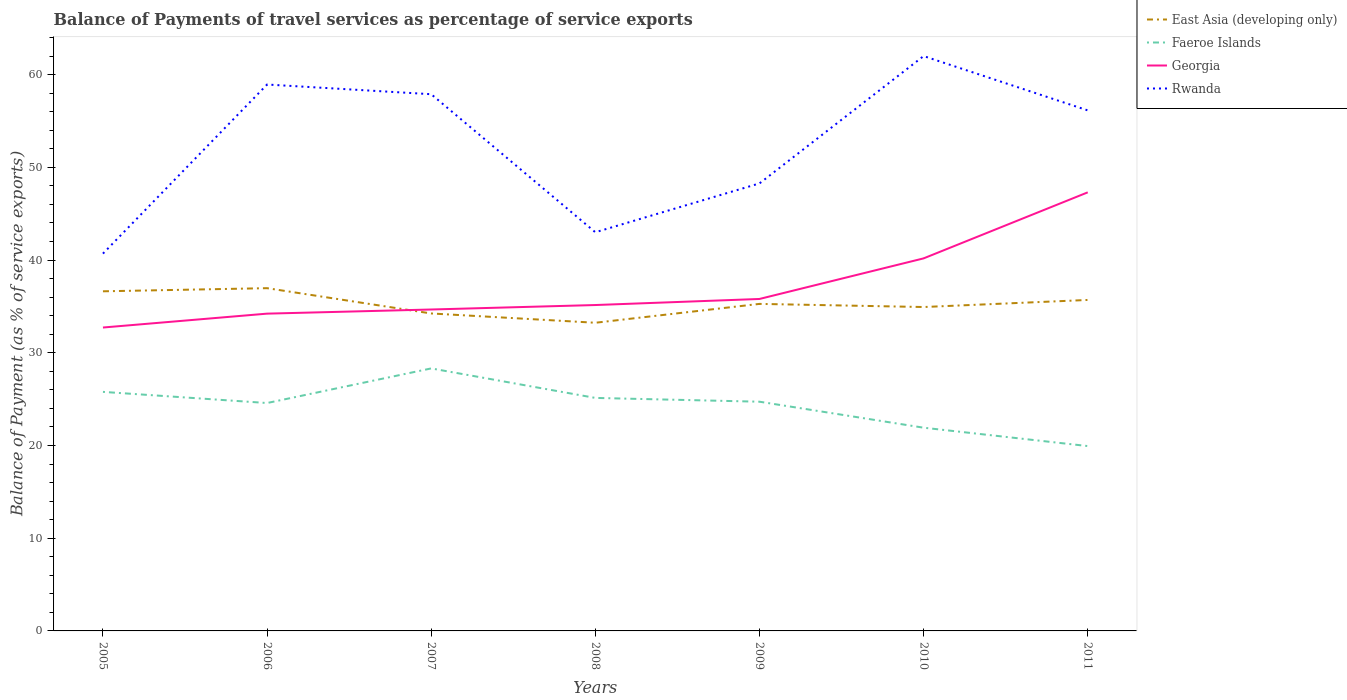How many different coloured lines are there?
Make the answer very short. 4. Is the number of lines equal to the number of legend labels?
Offer a very short reply. Yes. Across all years, what is the maximum balance of payments of travel services in Georgia?
Ensure brevity in your answer.  32.72. What is the total balance of payments of travel services in Rwanda in the graph?
Offer a very short reply. -13.14. What is the difference between the highest and the second highest balance of payments of travel services in Rwanda?
Give a very brief answer. 21.3. Is the balance of payments of travel services in East Asia (developing only) strictly greater than the balance of payments of travel services in Georgia over the years?
Make the answer very short. No. How many lines are there?
Ensure brevity in your answer.  4. What is the difference between two consecutive major ticks on the Y-axis?
Make the answer very short. 10. Are the values on the major ticks of Y-axis written in scientific E-notation?
Your answer should be compact. No. Does the graph contain grids?
Provide a succinct answer. No. Where does the legend appear in the graph?
Your answer should be compact. Top right. How many legend labels are there?
Give a very brief answer. 4. What is the title of the graph?
Offer a terse response. Balance of Payments of travel services as percentage of service exports. Does "Trinidad and Tobago" appear as one of the legend labels in the graph?
Keep it short and to the point. No. What is the label or title of the X-axis?
Your answer should be compact. Years. What is the label or title of the Y-axis?
Offer a terse response. Balance of Payment (as % of service exports). What is the Balance of Payment (as % of service exports) in East Asia (developing only) in 2005?
Your answer should be compact. 36.63. What is the Balance of Payment (as % of service exports) of Faeroe Islands in 2005?
Your answer should be very brief. 25.78. What is the Balance of Payment (as % of service exports) of Georgia in 2005?
Provide a short and direct response. 32.72. What is the Balance of Payment (as % of service exports) in Rwanda in 2005?
Your answer should be very brief. 40.69. What is the Balance of Payment (as % of service exports) in East Asia (developing only) in 2006?
Your answer should be compact. 36.96. What is the Balance of Payment (as % of service exports) of Faeroe Islands in 2006?
Ensure brevity in your answer.  24.58. What is the Balance of Payment (as % of service exports) in Georgia in 2006?
Provide a succinct answer. 34.22. What is the Balance of Payment (as % of service exports) in Rwanda in 2006?
Provide a short and direct response. 58.93. What is the Balance of Payment (as % of service exports) in East Asia (developing only) in 2007?
Offer a very short reply. 34.24. What is the Balance of Payment (as % of service exports) in Faeroe Islands in 2007?
Keep it short and to the point. 28.31. What is the Balance of Payment (as % of service exports) of Georgia in 2007?
Make the answer very short. 34.66. What is the Balance of Payment (as % of service exports) of Rwanda in 2007?
Provide a short and direct response. 57.88. What is the Balance of Payment (as % of service exports) of East Asia (developing only) in 2008?
Provide a short and direct response. 33.23. What is the Balance of Payment (as % of service exports) in Faeroe Islands in 2008?
Offer a very short reply. 25.13. What is the Balance of Payment (as % of service exports) in Georgia in 2008?
Keep it short and to the point. 35.15. What is the Balance of Payment (as % of service exports) in Rwanda in 2008?
Provide a succinct answer. 42.99. What is the Balance of Payment (as % of service exports) in East Asia (developing only) in 2009?
Your answer should be very brief. 35.27. What is the Balance of Payment (as % of service exports) of Faeroe Islands in 2009?
Provide a short and direct response. 24.72. What is the Balance of Payment (as % of service exports) of Georgia in 2009?
Your answer should be very brief. 35.8. What is the Balance of Payment (as % of service exports) of Rwanda in 2009?
Your answer should be compact. 48.26. What is the Balance of Payment (as % of service exports) in East Asia (developing only) in 2010?
Keep it short and to the point. 34.93. What is the Balance of Payment (as % of service exports) in Faeroe Islands in 2010?
Keep it short and to the point. 21.92. What is the Balance of Payment (as % of service exports) of Georgia in 2010?
Keep it short and to the point. 40.18. What is the Balance of Payment (as % of service exports) of Rwanda in 2010?
Keep it short and to the point. 61.99. What is the Balance of Payment (as % of service exports) in East Asia (developing only) in 2011?
Keep it short and to the point. 35.69. What is the Balance of Payment (as % of service exports) in Faeroe Islands in 2011?
Make the answer very short. 19.94. What is the Balance of Payment (as % of service exports) of Georgia in 2011?
Offer a terse response. 47.3. What is the Balance of Payment (as % of service exports) of Rwanda in 2011?
Provide a short and direct response. 56.14. Across all years, what is the maximum Balance of Payment (as % of service exports) of East Asia (developing only)?
Your answer should be very brief. 36.96. Across all years, what is the maximum Balance of Payment (as % of service exports) of Faeroe Islands?
Your response must be concise. 28.31. Across all years, what is the maximum Balance of Payment (as % of service exports) of Georgia?
Your answer should be very brief. 47.3. Across all years, what is the maximum Balance of Payment (as % of service exports) of Rwanda?
Your response must be concise. 61.99. Across all years, what is the minimum Balance of Payment (as % of service exports) of East Asia (developing only)?
Make the answer very short. 33.23. Across all years, what is the minimum Balance of Payment (as % of service exports) in Faeroe Islands?
Keep it short and to the point. 19.94. Across all years, what is the minimum Balance of Payment (as % of service exports) in Georgia?
Keep it short and to the point. 32.72. Across all years, what is the minimum Balance of Payment (as % of service exports) of Rwanda?
Provide a succinct answer. 40.69. What is the total Balance of Payment (as % of service exports) in East Asia (developing only) in the graph?
Give a very brief answer. 246.95. What is the total Balance of Payment (as % of service exports) in Faeroe Islands in the graph?
Offer a terse response. 170.37. What is the total Balance of Payment (as % of service exports) in Georgia in the graph?
Give a very brief answer. 260.02. What is the total Balance of Payment (as % of service exports) of Rwanda in the graph?
Provide a succinct answer. 366.89. What is the difference between the Balance of Payment (as % of service exports) in East Asia (developing only) in 2005 and that in 2006?
Give a very brief answer. -0.34. What is the difference between the Balance of Payment (as % of service exports) in Faeroe Islands in 2005 and that in 2006?
Your response must be concise. 1.2. What is the difference between the Balance of Payment (as % of service exports) of Georgia in 2005 and that in 2006?
Offer a terse response. -1.5. What is the difference between the Balance of Payment (as % of service exports) of Rwanda in 2005 and that in 2006?
Keep it short and to the point. -18.23. What is the difference between the Balance of Payment (as % of service exports) in East Asia (developing only) in 2005 and that in 2007?
Your response must be concise. 2.39. What is the difference between the Balance of Payment (as % of service exports) of Faeroe Islands in 2005 and that in 2007?
Your answer should be very brief. -2.53. What is the difference between the Balance of Payment (as % of service exports) of Georgia in 2005 and that in 2007?
Offer a very short reply. -1.94. What is the difference between the Balance of Payment (as % of service exports) in Rwanda in 2005 and that in 2007?
Your answer should be compact. -17.19. What is the difference between the Balance of Payment (as % of service exports) in East Asia (developing only) in 2005 and that in 2008?
Offer a very short reply. 3.39. What is the difference between the Balance of Payment (as % of service exports) in Faeroe Islands in 2005 and that in 2008?
Offer a terse response. 0.65. What is the difference between the Balance of Payment (as % of service exports) in Georgia in 2005 and that in 2008?
Ensure brevity in your answer.  -2.43. What is the difference between the Balance of Payment (as % of service exports) of Rwanda in 2005 and that in 2008?
Your answer should be very brief. -2.3. What is the difference between the Balance of Payment (as % of service exports) in East Asia (developing only) in 2005 and that in 2009?
Ensure brevity in your answer.  1.36. What is the difference between the Balance of Payment (as % of service exports) in Faeroe Islands in 2005 and that in 2009?
Offer a very short reply. 1.06. What is the difference between the Balance of Payment (as % of service exports) of Georgia in 2005 and that in 2009?
Give a very brief answer. -3.08. What is the difference between the Balance of Payment (as % of service exports) of Rwanda in 2005 and that in 2009?
Ensure brevity in your answer.  -7.57. What is the difference between the Balance of Payment (as % of service exports) in East Asia (developing only) in 2005 and that in 2010?
Your answer should be very brief. 1.7. What is the difference between the Balance of Payment (as % of service exports) in Faeroe Islands in 2005 and that in 2010?
Give a very brief answer. 3.86. What is the difference between the Balance of Payment (as % of service exports) of Georgia in 2005 and that in 2010?
Provide a succinct answer. -7.46. What is the difference between the Balance of Payment (as % of service exports) of Rwanda in 2005 and that in 2010?
Provide a short and direct response. -21.3. What is the difference between the Balance of Payment (as % of service exports) in East Asia (developing only) in 2005 and that in 2011?
Ensure brevity in your answer.  0.93. What is the difference between the Balance of Payment (as % of service exports) of Faeroe Islands in 2005 and that in 2011?
Make the answer very short. 5.84. What is the difference between the Balance of Payment (as % of service exports) of Georgia in 2005 and that in 2011?
Offer a very short reply. -14.58. What is the difference between the Balance of Payment (as % of service exports) of Rwanda in 2005 and that in 2011?
Make the answer very short. -15.45. What is the difference between the Balance of Payment (as % of service exports) of East Asia (developing only) in 2006 and that in 2007?
Offer a very short reply. 2.73. What is the difference between the Balance of Payment (as % of service exports) of Faeroe Islands in 2006 and that in 2007?
Ensure brevity in your answer.  -3.73. What is the difference between the Balance of Payment (as % of service exports) of Georgia in 2006 and that in 2007?
Your answer should be very brief. -0.45. What is the difference between the Balance of Payment (as % of service exports) of Rwanda in 2006 and that in 2007?
Keep it short and to the point. 1.05. What is the difference between the Balance of Payment (as % of service exports) of East Asia (developing only) in 2006 and that in 2008?
Offer a terse response. 3.73. What is the difference between the Balance of Payment (as % of service exports) in Faeroe Islands in 2006 and that in 2008?
Your response must be concise. -0.55. What is the difference between the Balance of Payment (as % of service exports) in Georgia in 2006 and that in 2008?
Your answer should be very brief. -0.93. What is the difference between the Balance of Payment (as % of service exports) in Rwanda in 2006 and that in 2008?
Your answer should be very brief. 15.93. What is the difference between the Balance of Payment (as % of service exports) of East Asia (developing only) in 2006 and that in 2009?
Your response must be concise. 1.7. What is the difference between the Balance of Payment (as % of service exports) of Faeroe Islands in 2006 and that in 2009?
Your response must be concise. -0.14. What is the difference between the Balance of Payment (as % of service exports) in Georgia in 2006 and that in 2009?
Your answer should be very brief. -1.58. What is the difference between the Balance of Payment (as % of service exports) in Rwanda in 2006 and that in 2009?
Your response must be concise. 10.66. What is the difference between the Balance of Payment (as % of service exports) of East Asia (developing only) in 2006 and that in 2010?
Your answer should be compact. 2.03. What is the difference between the Balance of Payment (as % of service exports) in Faeroe Islands in 2006 and that in 2010?
Provide a short and direct response. 2.66. What is the difference between the Balance of Payment (as % of service exports) in Georgia in 2006 and that in 2010?
Your answer should be compact. -5.96. What is the difference between the Balance of Payment (as % of service exports) of Rwanda in 2006 and that in 2010?
Your answer should be very brief. -3.07. What is the difference between the Balance of Payment (as % of service exports) of East Asia (developing only) in 2006 and that in 2011?
Keep it short and to the point. 1.27. What is the difference between the Balance of Payment (as % of service exports) of Faeroe Islands in 2006 and that in 2011?
Keep it short and to the point. 4.64. What is the difference between the Balance of Payment (as % of service exports) of Georgia in 2006 and that in 2011?
Give a very brief answer. -13.08. What is the difference between the Balance of Payment (as % of service exports) of Rwanda in 2006 and that in 2011?
Offer a terse response. 2.79. What is the difference between the Balance of Payment (as % of service exports) of Faeroe Islands in 2007 and that in 2008?
Your answer should be very brief. 3.18. What is the difference between the Balance of Payment (as % of service exports) of Georgia in 2007 and that in 2008?
Your answer should be compact. -0.48. What is the difference between the Balance of Payment (as % of service exports) of Rwanda in 2007 and that in 2008?
Give a very brief answer. 14.89. What is the difference between the Balance of Payment (as % of service exports) of East Asia (developing only) in 2007 and that in 2009?
Your response must be concise. -1.03. What is the difference between the Balance of Payment (as % of service exports) in Faeroe Islands in 2007 and that in 2009?
Your answer should be very brief. 3.59. What is the difference between the Balance of Payment (as % of service exports) of Georgia in 2007 and that in 2009?
Your answer should be very brief. -1.14. What is the difference between the Balance of Payment (as % of service exports) of Rwanda in 2007 and that in 2009?
Offer a terse response. 9.62. What is the difference between the Balance of Payment (as % of service exports) of East Asia (developing only) in 2007 and that in 2010?
Your response must be concise. -0.69. What is the difference between the Balance of Payment (as % of service exports) in Faeroe Islands in 2007 and that in 2010?
Provide a succinct answer. 6.39. What is the difference between the Balance of Payment (as % of service exports) of Georgia in 2007 and that in 2010?
Your response must be concise. -5.51. What is the difference between the Balance of Payment (as % of service exports) of Rwanda in 2007 and that in 2010?
Your answer should be very brief. -4.11. What is the difference between the Balance of Payment (as % of service exports) of East Asia (developing only) in 2007 and that in 2011?
Your answer should be compact. -1.46. What is the difference between the Balance of Payment (as % of service exports) of Faeroe Islands in 2007 and that in 2011?
Make the answer very short. 8.37. What is the difference between the Balance of Payment (as % of service exports) of Georgia in 2007 and that in 2011?
Ensure brevity in your answer.  -12.63. What is the difference between the Balance of Payment (as % of service exports) in Rwanda in 2007 and that in 2011?
Your answer should be very brief. 1.74. What is the difference between the Balance of Payment (as % of service exports) of East Asia (developing only) in 2008 and that in 2009?
Your answer should be very brief. -2.03. What is the difference between the Balance of Payment (as % of service exports) of Faeroe Islands in 2008 and that in 2009?
Your answer should be very brief. 0.41. What is the difference between the Balance of Payment (as % of service exports) of Georgia in 2008 and that in 2009?
Keep it short and to the point. -0.65. What is the difference between the Balance of Payment (as % of service exports) of Rwanda in 2008 and that in 2009?
Ensure brevity in your answer.  -5.27. What is the difference between the Balance of Payment (as % of service exports) in East Asia (developing only) in 2008 and that in 2010?
Offer a very short reply. -1.7. What is the difference between the Balance of Payment (as % of service exports) of Faeroe Islands in 2008 and that in 2010?
Provide a succinct answer. 3.21. What is the difference between the Balance of Payment (as % of service exports) of Georgia in 2008 and that in 2010?
Make the answer very short. -5.03. What is the difference between the Balance of Payment (as % of service exports) of East Asia (developing only) in 2008 and that in 2011?
Give a very brief answer. -2.46. What is the difference between the Balance of Payment (as % of service exports) in Faeroe Islands in 2008 and that in 2011?
Keep it short and to the point. 5.19. What is the difference between the Balance of Payment (as % of service exports) of Georgia in 2008 and that in 2011?
Ensure brevity in your answer.  -12.15. What is the difference between the Balance of Payment (as % of service exports) in Rwanda in 2008 and that in 2011?
Make the answer very short. -13.14. What is the difference between the Balance of Payment (as % of service exports) of East Asia (developing only) in 2009 and that in 2010?
Offer a very short reply. 0.34. What is the difference between the Balance of Payment (as % of service exports) of Faeroe Islands in 2009 and that in 2010?
Provide a short and direct response. 2.8. What is the difference between the Balance of Payment (as % of service exports) of Georgia in 2009 and that in 2010?
Your answer should be very brief. -4.38. What is the difference between the Balance of Payment (as % of service exports) in Rwanda in 2009 and that in 2010?
Provide a short and direct response. -13.73. What is the difference between the Balance of Payment (as % of service exports) of East Asia (developing only) in 2009 and that in 2011?
Keep it short and to the point. -0.43. What is the difference between the Balance of Payment (as % of service exports) in Faeroe Islands in 2009 and that in 2011?
Offer a very short reply. 4.78. What is the difference between the Balance of Payment (as % of service exports) of Georgia in 2009 and that in 2011?
Offer a terse response. -11.5. What is the difference between the Balance of Payment (as % of service exports) of Rwanda in 2009 and that in 2011?
Your answer should be compact. -7.88. What is the difference between the Balance of Payment (as % of service exports) in East Asia (developing only) in 2010 and that in 2011?
Provide a short and direct response. -0.76. What is the difference between the Balance of Payment (as % of service exports) of Faeroe Islands in 2010 and that in 2011?
Your response must be concise. 1.98. What is the difference between the Balance of Payment (as % of service exports) of Georgia in 2010 and that in 2011?
Your answer should be very brief. -7.12. What is the difference between the Balance of Payment (as % of service exports) of Rwanda in 2010 and that in 2011?
Make the answer very short. 5.86. What is the difference between the Balance of Payment (as % of service exports) of East Asia (developing only) in 2005 and the Balance of Payment (as % of service exports) of Faeroe Islands in 2006?
Ensure brevity in your answer.  12.05. What is the difference between the Balance of Payment (as % of service exports) of East Asia (developing only) in 2005 and the Balance of Payment (as % of service exports) of Georgia in 2006?
Ensure brevity in your answer.  2.41. What is the difference between the Balance of Payment (as % of service exports) of East Asia (developing only) in 2005 and the Balance of Payment (as % of service exports) of Rwanda in 2006?
Ensure brevity in your answer.  -22.3. What is the difference between the Balance of Payment (as % of service exports) of Faeroe Islands in 2005 and the Balance of Payment (as % of service exports) of Georgia in 2006?
Offer a terse response. -8.44. What is the difference between the Balance of Payment (as % of service exports) of Faeroe Islands in 2005 and the Balance of Payment (as % of service exports) of Rwanda in 2006?
Ensure brevity in your answer.  -33.15. What is the difference between the Balance of Payment (as % of service exports) in Georgia in 2005 and the Balance of Payment (as % of service exports) in Rwanda in 2006?
Offer a terse response. -26.21. What is the difference between the Balance of Payment (as % of service exports) in East Asia (developing only) in 2005 and the Balance of Payment (as % of service exports) in Faeroe Islands in 2007?
Your response must be concise. 8.32. What is the difference between the Balance of Payment (as % of service exports) of East Asia (developing only) in 2005 and the Balance of Payment (as % of service exports) of Georgia in 2007?
Offer a terse response. 1.96. What is the difference between the Balance of Payment (as % of service exports) in East Asia (developing only) in 2005 and the Balance of Payment (as % of service exports) in Rwanda in 2007?
Your response must be concise. -21.25. What is the difference between the Balance of Payment (as % of service exports) in Faeroe Islands in 2005 and the Balance of Payment (as % of service exports) in Georgia in 2007?
Ensure brevity in your answer.  -8.88. What is the difference between the Balance of Payment (as % of service exports) in Faeroe Islands in 2005 and the Balance of Payment (as % of service exports) in Rwanda in 2007?
Ensure brevity in your answer.  -32.1. What is the difference between the Balance of Payment (as % of service exports) of Georgia in 2005 and the Balance of Payment (as % of service exports) of Rwanda in 2007?
Your response must be concise. -25.16. What is the difference between the Balance of Payment (as % of service exports) in East Asia (developing only) in 2005 and the Balance of Payment (as % of service exports) in Faeroe Islands in 2008?
Your response must be concise. 11.5. What is the difference between the Balance of Payment (as % of service exports) of East Asia (developing only) in 2005 and the Balance of Payment (as % of service exports) of Georgia in 2008?
Ensure brevity in your answer.  1.48. What is the difference between the Balance of Payment (as % of service exports) in East Asia (developing only) in 2005 and the Balance of Payment (as % of service exports) in Rwanda in 2008?
Keep it short and to the point. -6.37. What is the difference between the Balance of Payment (as % of service exports) in Faeroe Islands in 2005 and the Balance of Payment (as % of service exports) in Georgia in 2008?
Make the answer very short. -9.37. What is the difference between the Balance of Payment (as % of service exports) in Faeroe Islands in 2005 and the Balance of Payment (as % of service exports) in Rwanda in 2008?
Make the answer very short. -17.21. What is the difference between the Balance of Payment (as % of service exports) of Georgia in 2005 and the Balance of Payment (as % of service exports) of Rwanda in 2008?
Your answer should be very brief. -10.27. What is the difference between the Balance of Payment (as % of service exports) of East Asia (developing only) in 2005 and the Balance of Payment (as % of service exports) of Faeroe Islands in 2009?
Ensure brevity in your answer.  11.91. What is the difference between the Balance of Payment (as % of service exports) of East Asia (developing only) in 2005 and the Balance of Payment (as % of service exports) of Georgia in 2009?
Ensure brevity in your answer.  0.83. What is the difference between the Balance of Payment (as % of service exports) of East Asia (developing only) in 2005 and the Balance of Payment (as % of service exports) of Rwanda in 2009?
Ensure brevity in your answer.  -11.64. What is the difference between the Balance of Payment (as % of service exports) of Faeroe Islands in 2005 and the Balance of Payment (as % of service exports) of Georgia in 2009?
Give a very brief answer. -10.02. What is the difference between the Balance of Payment (as % of service exports) in Faeroe Islands in 2005 and the Balance of Payment (as % of service exports) in Rwanda in 2009?
Offer a very short reply. -22.48. What is the difference between the Balance of Payment (as % of service exports) in Georgia in 2005 and the Balance of Payment (as % of service exports) in Rwanda in 2009?
Your answer should be compact. -15.54. What is the difference between the Balance of Payment (as % of service exports) in East Asia (developing only) in 2005 and the Balance of Payment (as % of service exports) in Faeroe Islands in 2010?
Ensure brevity in your answer.  14.71. What is the difference between the Balance of Payment (as % of service exports) in East Asia (developing only) in 2005 and the Balance of Payment (as % of service exports) in Georgia in 2010?
Your response must be concise. -3.55. What is the difference between the Balance of Payment (as % of service exports) of East Asia (developing only) in 2005 and the Balance of Payment (as % of service exports) of Rwanda in 2010?
Provide a succinct answer. -25.37. What is the difference between the Balance of Payment (as % of service exports) of Faeroe Islands in 2005 and the Balance of Payment (as % of service exports) of Georgia in 2010?
Your answer should be very brief. -14.4. What is the difference between the Balance of Payment (as % of service exports) in Faeroe Islands in 2005 and the Balance of Payment (as % of service exports) in Rwanda in 2010?
Provide a succinct answer. -36.21. What is the difference between the Balance of Payment (as % of service exports) of Georgia in 2005 and the Balance of Payment (as % of service exports) of Rwanda in 2010?
Make the answer very short. -29.27. What is the difference between the Balance of Payment (as % of service exports) in East Asia (developing only) in 2005 and the Balance of Payment (as % of service exports) in Faeroe Islands in 2011?
Your answer should be compact. 16.69. What is the difference between the Balance of Payment (as % of service exports) of East Asia (developing only) in 2005 and the Balance of Payment (as % of service exports) of Georgia in 2011?
Make the answer very short. -10.67. What is the difference between the Balance of Payment (as % of service exports) of East Asia (developing only) in 2005 and the Balance of Payment (as % of service exports) of Rwanda in 2011?
Give a very brief answer. -19.51. What is the difference between the Balance of Payment (as % of service exports) of Faeroe Islands in 2005 and the Balance of Payment (as % of service exports) of Georgia in 2011?
Offer a very short reply. -21.52. What is the difference between the Balance of Payment (as % of service exports) of Faeroe Islands in 2005 and the Balance of Payment (as % of service exports) of Rwanda in 2011?
Your answer should be compact. -30.36. What is the difference between the Balance of Payment (as % of service exports) in Georgia in 2005 and the Balance of Payment (as % of service exports) in Rwanda in 2011?
Ensure brevity in your answer.  -23.42. What is the difference between the Balance of Payment (as % of service exports) of East Asia (developing only) in 2006 and the Balance of Payment (as % of service exports) of Faeroe Islands in 2007?
Ensure brevity in your answer.  8.65. What is the difference between the Balance of Payment (as % of service exports) in East Asia (developing only) in 2006 and the Balance of Payment (as % of service exports) in Georgia in 2007?
Give a very brief answer. 2.3. What is the difference between the Balance of Payment (as % of service exports) in East Asia (developing only) in 2006 and the Balance of Payment (as % of service exports) in Rwanda in 2007?
Provide a short and direct response. -20.92. What is the difference between the Balance of Payment (as % of service exports) in Faeroe Islands in 2006 and the Balance of Payment (as % of service exports) in Georgia in 2007?
Offer a terse response. -10.09. What is the difference between the Balance of Payment (as % of service exports) of Faeroe Islands in 2006 and the Balance of Payment (as % of service exports) of Rwanda in 2007?
Provide a short and direct response. -33.3. What is the difference between the Balance of Payment (as % of service exports) of Georgia in 2006 and the Balance of Payment (as % of service exports) of Rwanda in 2007?
Provide a short and direct response. -23.66. What is the difference between the Balance of Payment (as % of service exports) of East Asia (developing only) in 2006 and the Balance of Payment (as % of service exports) of Faeroe Islands in 2008?
Ensure brevity in your answer.  11.84. What is the difference between the Balance of Payment (as % of service exports) in East Asia (developing only) in 2006 and the Balance of Payment (as % of service exports) in Georgia in 2008?
Offer a terse response. 1.82. What is the difference between the Balance of Payment (as % of service exports) of East Asia (developing only) in 2006 and the Balance of Payment (as % of service exports) of Rwanda in 2008?
Make the answer very short. -6.03. What is the difference between the Balance of Payment (as % of service exports) in Faeroe Islands in 2006 and the Balance of Payment (as % of service exports) in Georgia in 2008?
Provide a short and direct response. -10.57. What is the difference between the Balance of Payment (as % of service exports) of Faeroe Islands in 2006 and the Balance of Payment (as % of service exports) of Rwanda in 2008?
Keep it short and to the point. -18.42. What is the difference between the Balance of Payment (as % of service exports) in Georgia in 2006 and the Balance of Payment (as % of service exports) in Rwanda in 2008?
Your response must be concise. -8.78. What is the difference between the Balance of Payment (as % of service exports) of East Asia (developing only) in 2006 and the Balance of Payment (as % of service exports) of Faeroe Islands in 2009?
Your response must be concise. 12.24. What is the difference between the Balance of Payment (as % of service exports) of East Asia (developing only) in 2006 and the Balance of Payment (as % of service exports) of Georgia in 2009?
Keep it short and to the point. 1.16. What is the difference between the Balance of Payment (as % of service exports) in East Asia (developing only) in 2006 and the Balance of Payment (as % of service exports) in Rwanda in 2009?
Give a very brief answer. -11.3. What is the difference between the Balance of Payment (as % of service exports) in Faeroe Islands in 2006 and the Balance of Payment (as % of service exports) in Georgia in 2009?
Provide a short and direct response. -11.22. What is the difference between the Balance of Payment (as % of service exports) in Faeroe Islands in 2006 and the Balance of Payment (as % of service exports) in Rwanda in 2009?
Your response must be concise. -23.68. What is the difference between the Balance of Payment (as % of service exports) of Georgia in 2006 and the Balance of Payment (as % of service exports) of Rwanda in 2009?
Make the answer very short. -14.04. What is the difference between the Balance of Payment (as % of service exports) of East Asia (developing only) in 2006 and the Balance of Payment (as % of service exports) of Faeroe Islands in 2010?
Keep it short and to the point. 15.05. What is the difference between the Balance of Payment (as % of service exports) in East Asia (developing only) in 2006 and the Balance of Payment (as % of service exports) in Georgia in 2010?
Make the answer very short. -3.21. What is the difference between the Balance of Payment (as % of service exports) in East Asia (developing only) in 2006 and the Balance of Payment (as % of service exports) in Rwanda in 2010?
Your answer should be very brief. -25.03. What is the difference between the Balance of Payment (as % of service exports) in Faeroe Islands in 2006 and the Balance of Payment (as % of service exports) in Georgia in 2010?
Keep it short and to the point. -15.6. What is the difference between the Balance of Payment (as % of service exports) of Faeroe Islands in 2006 and the Balance of Payment (as % of service exports) of Rwanda in 2010?
Make the answer very short. -37.42. What is the difference between the Balance of Payment (as % of service exports) in Georgia in 2006 and the Balance of Payment (as % of service exports) in Rwanda in 2010?
Provide a short and direct response. -27.78. What is the difference between the Balance of Payment (as % of service exports) in East Asia (developing only) in 2006 and the Balance of Payment (as % of service exports) in Faeroe Islands in 2011?
Ensure brevity in your answer.  17.03. What is the difference between the Balance of Payment (as % of service exports) in East Asia (developing only) in 2006 and the Balance of Payment (as % of service exports) in Georgia in 2011?
Your answer should be compact. -10.33. What is the difference between the Balance of Payment (as % of service exports) of East Asia (developing only) in 2006 and the Balance of Payment (as % of service exports) of Rwanda in 2011?
Your answer should be very brief. -19.17. What is the difference between the Balance of Payment (as % of service exports) in Faeroe Islands in 2006 and the Balance of Payment (as % of service exports) in Georgia in 2011?
Provide a short and direct response. -22.72. What is the difference between the Balance of Payment (as % of service exports) in Faeroe Islands in 2006 and the Balance of Payment (as % of service exports) in Rwanda in 2011?
Provide a short and direct response. -31.56. What is the difference between the Balance of Payment (as % of service exports) of Georgia in 2006 and the Balance of Payment (as % of service exports) of Rwanda in 2011?
Your answer should be compact. -21.92. What is the difference between the Balance of Payment (as % of service exports) in East Asia (developing only) in 2007 and the Balance of Payment (as % of service exports) in Faeroe Islands in 2008?
Ensure brevity in your answer.  9.11. What is the difference between the Balance of Payment (as % of service exports) of East Asia (developing only) in 2007 and the Balance of Payment (as % of service exports) of Georgia in 2008?
Ensure brevity in your answer.  -0.91. What is the difference between the Balance of Payment (as % of service exports) in East Asia (developing only) in 2007 and the Balance of Payment (as % of service exports) in Rwanda in 2008?
Make the answer very short. -8.76. What is the difference between the Balance of Payment (as % of service exports) in Faeroe Islands in 2007 and the Balance of Payment (as % of service exports) in Georgia in 2008?
Your answer should be very brief. -6.84. What is the difference between the Balance of Payment (as % of service exports) in Faeroe Islands in 2007 and the Balance of Payment (as % of service exports) in Rwanda in 2008?
Give a very brief answer. -14.68. What is the difference between the Balance of Payment (as % of service exports) of Georgia in 2007 and the Balance of Payment (as % of service exports) of Rwanda in 2008?
Keep it short and to the point. -8.33. What is the difference between the Balance of Payment (as % of service exports) in East Asia (developing only) in 2007 and the Balance of Payment (as % of service exports) in Faeroe Islands in 2009?
Ensure brevity in your answer.  9.52. What is the difference between the Balance of Payment (as % of service exports) of East Asia (developing only) in 2007 and the Balance of Payment (as % of service exports) of Georgia in 2009?
Keep it short and to the point. -1.56. What is the difference between the Balance of Payment (as % of service exports) of East Asia (developing only) in 2007 and the Balance of Payment (as % of service exports) of Rwanda in 2009?
Give a very brief answer. -14.03. What is the difference between the Balance of Payment (as % of service exports) in Faeroe Islands in 2007 and the Balance of Payment (as % of service exports) in Georgia in 2009?
Ensure brevity in your answer.  -7.49. What is the difference between the Balance of Payment (as % of service exports) in Faeroe Islands in 2007 and the Balance of Payment (as % of service exports) in Rwanda in 2009?
Your answer should be very brief. -19.95. What is the difference between the Balance of Payment (as % of service exports) of Georgia in 2007 and the Balance of Payment (as % of service exports) of Rwanda in 2009?
Keep it short and to the point. -13.6. What is the difference between the Balance of Payment (as % of service exports) of East Asia (developing only) in 2007 and the Balance of Payment (as % of service exports) of Faeroe Islands in 2010?
Your answer should be compact. 12.32. What is the difference between the Balance of Payment (as % of service exports) of East Asia (developing only) in 2007 and the Balance of Payment (as % of service exports) of Georgia in 2010?
Provide a succinct answer. -5.94. What is the difference between the Balance of Payment (as % of service exports) in East Asia (developing only) in 2007 and the Balance of Payment (as % of service exports) in Rwanda in 2010?
Provide a succinct answer. -27.76. What is the difference between the Balance of Payment (as % of service exports) of Faeroe Islands in 2007 and the Balance of Payment (as % of service exports) of Georgia in 2010?
Make the answer very short. -11.87. What is the difference between the Balance of Payment (as % of service exports) in Faeroe Islands in 2007 and the Balance of Payment (as % of service exports) in Rwanda in 2010?
Provide a succinct answer. -33.68. What is the difference between the Balance of Payment (as % of service exports) of Georgia in 2007 and the Balance of Payment (as % of service exports) of Rwanda in 2010?
Your response must be concise. -27.33. What is the difference between the Balance of Payment (as % of service exports) of East Asia (developing only) in 2007 and the Balance of Payment (as % of service exports) of Faeroe Islands in 2011?
Keep it short and to the point. 14.3. What is the difference between the Balance of Payment (as % of service exports) in East Asia (developing only) in 2007 and the Balance of Payment (as % of service exports) in Georgia in 2011?
Your answer should be compact. -13.06. What is the difference between the Balance of Payment (as % of service exports) in East Asia (developing only) in 2007 and the Balance of Payment (as % of service exports) in Rwanda in 2011?
Offer a very short reply. -21.9. What is the difference between the Balance of Payment (as % of service exports) of Faeroe Islands in 2007 and the Balance of Payment (as % of service exports) of Georgia in 2011?
Keep it short and to the point. -18.99. What is the difference between the Balance of Payment (as % of service exports) in Faeroe Islands in 2007 and the Balance of Payment (as % of service exports) in Rwanda in 2011?
Keep it short and to the point. -27.83. What is the difference between the Balance of Payment (as % of service exports) in Georgia in 2007 and the Balance of Payment (as % of service exports) in Rwanda in 2011?
Provide a succinct answer. -21.47. What is the difference between the Balance of Payment (as % of service exports) of East Asia (developing only) in 2008 and the Balance of Payment (as % of service exports) of Faeroe Islands in 2009?
Make the answer very short. 8.51. What is the difference between the Balance of Payment (as % of service exports) of East Asia (developing only) in 2008 and the Balance of Payment (as % of service exports) of Georgia in 2009?
Provide a short and direct response. -2.57. What is the difference between the Balance of Payment (as % of service exports) of East Asia (developing only) in 2008 and the Balance of Payment (as % of service exports) of Rwanda in 2009?
Your answer should be compact. -15.03. What is the difference between the Balance of Payment (as % of service exports) in Faeroe Islands in 2008 and the Balance of Payment (as % of service exports) in Georgia in 2009?
Make the answer very short. -10.67. What is the difference between the Balance of Payment (as % of service exports) in Faeroe Islands in 2008 and the Balance of Payment (as % of service exports) in Rwanda in 2009?
Give a very brief answer. -23.13. What is the difference between the Balance of Payment (as % of service exports) of Georgia in 2008 and the Balance of Payment (as % of service exports) of Rwanda in 2009?
Your answer should be very brief. -13.12. What is the difference between the Balance of Payment (as % of service exports) of East Asia (developing only) in 2008 and the Balance of Payment (as % of service exports) of Faeroe Islands in 2010?
Your response must be concise. 11.32. What is the difference between the Balance of Payment (as % of service exports) of East Asia (developing only) in 2008 and the Balance of Payment (as % of service exports) of Georgia in 2010?
Offer a very short reply. -6.94. What is the difference between the Balance of Payment (as % of service exports) of East Asia (developing only) in 2008 and the Balance of Payment (as % of service exports) of Rwanda in 2010?
Provide a succinct answer. -28.76. What is the difference between the Balance of Payment (as % of service exports) in Faeroe Islands in 2008 and the Balance of Payment (as % of service exports) in Georgia in 2010?
Offer a terse response. -15.05. What is the difference between the Balance of Payment (as % of service exports) of Faeroe Islands in 2008 and the Balance of Payment (as % of service exports) of Rwanda in 2010?
Your response must be concise. -36.87. What is the difference between the Balance of Payment (as % of service exports) in Georgia in 2008 and the Balance of Payment (as % of service exports) in Rwanda in 2010?
Provide a succinct answer. -26.85. What is the difference between the Balance of Payment (as % of service exports) in East Asia (developing only) in 2008 and the Balance of Payment (as % of service exports) in Faeroe Islands in 2011?
Make the answer very short. 13.3. What is the difference between the Balance of Payment (as % of service exports) in East Asia (developing only) in 2008 and the Balance of Payment (as % of service exports) in Georgia in 2011?
Offer a very short reply. -14.06. What is the difference between the Balance of Payment (as % of service exports) of East Asia (developing only) in 2008 and the Balance of Payment (as % of service exports) of Rwanda in 2011?
Give a very brief answer. -22.9. What is the difference between the Balance of Payment (as % of service exports) in Faeroe Islands in 2008 and the Balance of Payment (as % of service exports) in Georgia in 2011?
Offer a terse response. -22.17. What is the difference between the Balance of Payment (as % of service exports) in Faeroe Islands in 2008 and the Balance of Payment (as % of service exports) in Rwanda in 2011?
Make the answer very short. -31.01. What is the difference between the Balance of Payment (as % of service exports) of Georgia in 2008 and the Balance of Payment (as % of service exports) of Rwanda in 2011?
Your answer should be compact. -20.99. What is the difference between the Balance of Payment (as % of service exports) in East Asia (developing only) in 2009 and the Balance of Payment (as % of service exports) in Faeroe Islands in 2010?
Give a very brief answer. 13.35. What is the difference between the Balance of Payment (as % of service exports) in East Asia (developing only) in 2009 and the Balance of Payment (as % of service exports) in Georgia in 2010?
Provide a succinct answer. -4.91. What is the difference between the Balance of Payment (as % of service exports) in East Asia (developing only) in 2009 and the Balance of Payment (as % of service exports) in Rwanda in 2010?
Ensure brevity in your answer.  -26.73. What is the difference between the Balance of Payment (as % of service exports) in Faeroe Islands in 2009 and the Balance of Payment (as % of service exports) in Georgia in 2010?
Keep it short and to the point. -15.46. What is the difference between the Balance of Payment (as % of service exports) of Faeroe Islands in 2009 and the Balance of Payment (as % of service exports) of Rwanda in 2010?
Your answer should be compact. -37.27. What is the difference between the Balance of Payment (as % of service exports) in Georgia in 2009 and the Balance of Payment (as % of service exports) in Rwanda in 2010?
Offer a terse response. -26.19. What is the difference between the Balance of Payment (as % of service exports) in East Asia (developing only) in 2009 and the Balance of Payment (as % of service exports) in Faeroe Islands in 2011?
Provide a short and direct response. 15.33. What is the difference between the Balance of Payment (as % of service exports) in East Asia (developing only) in 2009 and the Balance of Payment (as % of service exports) in Georgia in 2011?
Provide a succinct answer. -12.03. What is the difference between the Balance of Payment (as % of service exports) of East Asia (developing only) in 2009 and the Balance of Payment (as % of service exports) of Rwanda in 2011?
Offer a very short reply. -20.87. What is the difference between the Balance of Payment (as % of service exports) of Faeroe Islands in 2009 and the Balance of Payment (as % of service exports) of Georgia in 2011?
Provide a short and direct response. -22.58. What is the difference between the Balance of Payment (as % of service exports) in Faeroe Islands in 2009 and the Balance of Payment (as % of service exports) in Rwanda in 2011?
Your response must be concise. -31.42. What is the difference between the Balance of Payment (as % of service exports) in Georgia in 2009 and the Balance of Payment (as % of service exports) in Rwanda in 2011?
Offer a very short reply. -20.34. What is the difference between the Balance of Payment (as % of service exports) in East Asia (developing only) in 2010 and the Balance of Payment (as % of service exports) in Faeroe Islands in 2011?
Provide a succinct answer. 14.99. What is the difference between the Balance of Payment (as % of service exports) in East Asia (developing only) in 2010 and the Balance of Payment (as % of service exports) in Georgia in 2011?
Keep it short and to the point. -12.37. What is the difference between the Balance of Payment (as % of service exports) in East Asia (developing only) in 2010 and the Balance of Payment (as % of service exports) in Rwanda in 2011?
Give a very brief answer. -21.21. What is the difference between the Balance of Payment (as % of service exports) of Faeroe Islands in 2010 and the Balance of Payment (as % of service exports) of Georgia in 2011?
Make the answer very short. -25.38. What is the difference between the Balance of Payment (as % of service exports) of Faeroe Islands in 2010 and the Balance of Payment (as % of service exports) of Rwanda in 2011?
Your response must be concise. -34.22. What is the difference between the Balance of Payment (as % of service exports) of Georgia in 2010 and the Balance of Payment (as % of service exports) of Rwanda in 2011?
Give a very brief answer. -15.96. What is the average Balance of Payment (as % of service exports) in East Asia (developing only) per year?
Offer a very short reply. 35.28. What is the average Balance of Payment (as % of service exports) of Faeroe Islands per year?
Keep it short and to the point. 24.34. What is the average Balance of Payment (as % of service exports) in Georgia per year?
Your answer should be very brief. 37.15. What is the average Balance of Payment (as % of service exports) in Rwanda per year?
Offer a very short reply. 52.41. In the year 2005, what is the difference between the Balance of Payment (as % of service exports) of East Asia (developing only) and Balance of Payment (as % of service exports) of Faeroe Islands?
Your answer should be compact. 10.85. In the year 2005, what is the difference between the Balance of Payment (as % of service exports) in East Asia (developing only) and Balance of Payment (as % of service exports) in Georgia?
Make the answer very short. 3.91. In the year 2005, what is the difference between the Balance of Payment (as % of service exports) in East Asia (developing only) and Balance of Payment (as % of service exports) in Rwanda?
Your answer should be very brief. -4.07. In the year 2005, what is the difference between the Balance of Payment (as % of service exports) in Faeroe Islands and Balance of Payment (as % of service exports) in Georgia?
Offer a very short reply. -6.94. In the year 2005, what is the difference between the Balance of Payment (as % of service exports) of Faeroe Islands and Balance of Payment (as % of service exports) of Rwanda?
Keep it short and to the point. -14.91. In the year 2005, what is the difference between the Balance of Payment (as % of service exports) of Georgia and Balance of Payment (as % of service exports) of Rwanda?
Ensure brevity in your answer.  -7.97. In the year 2006, what is the difference between the Balance of Payment (as % of service exports) in East Asia (developing only) and Balance of Payment (as % of service exports) in Faeroe Islands?
Provide a short and direct response. 12.39. In the year 2006, what is the difference between the Balance of Payment (as % of service exports) of East Asia (developing only) and Balance of Payment (as % of service exports) of Georgia?
Your answer should be compact. 2.75. In the year 2006, what is the difference between the Balance of Payment (as % of service exports) in East Asia (developing only) and Balance of Payment (as % of service exports) in Rwanda?
Make the answer very short. -21.96. In the year 2006, what is the difference between the Balance of Payment (as % of service exports) in Faeroe Islands and Balance of Payment (as % of service exports) in Georgia?
Your answer should be very brief. -9.64. In the year 2006, what is the difference between the Balance of Payment (as % of service exports) in Faeroe Islands and Balance of Payment (as % of service exports) in Rwanda?
Provide a short and direct response. -34.35. In the year 2006, what is the difference between the Balance of Payment (as % of service exports) of Georgia and Balance of Payment (as % of service exports) of Rwanda?
Provide a succinct answer. -24.71. In the year 2007, what is the difference between the Balance of Payment (as % of service exports) in East Asia (developing only) and Balance of Payment (as % of service exports) in Faeroe Islands?
Provide a short and direct response. 5.93. In the year 2007, what is the difference between the Balance of Payment (as % of service exports) of East Asia (developing only) and Balance of Payment (as % of service exports) of Georgia?
Keep it short and to the point. -0.43. In the year 2007, what is the difference between the Balance of Payment (as % of service exports) in East Asia (developing only) and Balance of Payment (as % of service exports) in Rwanda?
Make the answer very short. -23.64. In the year 2007, what is the difference between the Balance of Payment (as % of service exports) of Faeroe Islands and Balance of Payment (as % of service exports) of Georgia?
Your response must be concise. -6.35. In the year 2007, what is the difference between the Balance of Payment (as % of service exports) of Faeroe Islands and Balance of Payment (as % of service exports) of Rwanda?
Make the answer very short. -29.57. In the year 2007, what is the difference between the Balance of Payment (as % of service exports) in Georgia and Balance of Payment (as % of service exports) in Rwanda?
Offer a very short reply. -23.22. In the year 2008, what is the difference between the Balance of Payment (as % of service exports) of East Asia (developing only) and Balance of Payment (as % of service exports) of Faeroe Islands?
Give a very brief answer. 8.11. In the year 2008, what is the difference between the Balance of Payment (as % of service exports) of East Asia (developing only) and Balance of Payment (as % of service exports) of Georgia?
Your answer should be very brief. -1.91. In the year 2008, what is the difference between the Balance of Payment (as % of service exports) of East Asia (developing only) and Balance of Payment (as % of service exports) of Rwanda?
Make the answer very short. -9.76. In the year 2008, what is the difference between the Balance of Payment (as % of service exports) of Faeroe Islands and Balance of Payment (as % of service exports) of Georgia?
Make the answer very short. -10.02. In the year 2008, what is the difference between the Balance of Payment (as % of service exports) of Faeroe Islands and Balance of Payment (as % of service exports) of Rwanda?
Make the answer very short. -17.87. In the year 2008, what is the difference between the Balance of Payment (as % of service exports) in Georgia and Balance of Payment (as % of service exports) in Rwanda?
Keep it short and to the point. -7.85. In the year 2009, what is the difference between the Balance of Payment (as % of service exports) of East Asia (developing only) and Balance of Payment (as % of service exports) of Faeroe Islands?
Keep it short and to the point. 10.55. In the year 2009, what is the difference between the Balance of Payment (as % of service exports) of East Asia (developing only) and Balance of Payment (as % of service exports) of Georgia?
Offer a terse response. -0.53. In the year 2009, what is the difference between the Balance of Payment (as % of service exports) of East Asia (developing only) and Balance of Payment (as % of service exports) of Rwanda?
Provide a short and direct response. -12.99. In the year 2009, what is the difference between the Balance of Payment (as % of service exports) in Faeroe Islands and Balance of Payment (as % of service exports) in Georgia?
Your answer should be very brief. -11.08. In the year 2009, what is the difference between the Balance of Payment (as % of service exports) of Faeroe Islands and Balance of Payment (as % of service exports) of Rwanda?
Provide a succinct answer. -23.54. In the year 2009, what is the difference between the Balance of Payment (as % of service exports) of Georgia and Balance of Payment (as % of service exports) of Rwanda?
Offer a very short reply. -12.46. In the year 2010, what is the difference between the Balance of Payment (as % of service exports) in East Asia (developing only) and Balance of Payment (as % of service exports) in Faeroe Islands?
Offer a terse response. 13.01. In the year 2010, what is the difference between the Balance of Payment (as % of service exports) of East Asia (developing only) and Balance of Payment (as % of service exports) of Georgia?
Give a very brief answer. -5.25. In the year 2010, what is the difference between the Balance of Payment (as % of service exports) in East Asia (developing only) and Balance of Payment (as % of service exports) in Rwanda?
Your response must be concise. -27.06. In the year 2010, what is the difference between the Balance of Payment (as % of service exports) in Faeroe Islands and Balance of Payment (as % of service exports) in Georgia?
Your response must be concise. -18.26. In the year 2010, what is the difference between the Balance of Payment (as % of service exports) in Faeroe Islands and Balance of Payment (as % of service exports) in Rwanda?
Offer a terse response. -40.08. In the year 2010, what is the difference between the Balance of Payment (as % of service exports) of Georgia and Balance of Payment (as % of service exports) of Rwanda?
Provide a short and direct response. -21.82. In the year 2011, what is the difference between the Balance of Payment (as % of service exports) of East Asia (developing only) and Balance of Payment (as % of service exports) of Faeroe Islands?
Provide a short and direct response. 15.76. In the year 2011, what is the difference between the Balance of Payment (as % of service exports) in East Asia (developing only) and Balance of Payment (as % of service exports) in Georgia?
Give a very brief answer. -11.6. In the year 2011, what is the difference between the Balance of Payment (as % of service exports) of East Asia (developing only) and Balance of Payment (as % of service exports) of Rwanda?
Your answer should be compact. -20.44. In the year 2011, what is the difference between the Balance of Payment (as % of service exports) in Faeroe Islands and Balance of Payment (as % of service exports) in Georgia?
Keep it short and to the point. -27.36. In the year 2011, what is the difference between the Balance of Payment (as % of service exports) in Faeroe Islands and Balance of Payment (as % of service exports) in Rwanda?
Keep it short and to the point. -36.2. In the year 2011, what is the difference between the Balance of Payment (as % of service exports) of Georgia and Balance of Payment (as % of service exports) of Rwanda?
Offer a very short reply. -8.84. What is the ratio of the Balance of Payment (as % of service exports) of East Asia (developing only) in 2005 to that in 2006?
Your answer should be very brief. 0.99. What is the ratio of the Balance of Payment (as % of service exports) of Faeroe Islands in 2005 to that in 2006?
Provide a succinct answer. 1.05. What is the ratio of the Balance of Payment (as % of service exports) of Georgia in 2005 to that in 2006?
Keep it short and to the point. 0.96. What is the ratio of the Balance of Payment (as % of service exports) of Rwanda in 2005 to that in 2006?
Ensure brevity in your answer.  0.69. What is the ratio of the Balance of Payment (as % of service exports) in East Asia (developing only) in 2005 to that in 2007?
Your response must be concise. 1.07. What is the ratio of the Balance of Payment (as % of service exports) in Faeroe Islands in 2005 to that in 2007?
Provide a succinct answer. 0.91. What is the ratio of the Balance of Payment (as % of service exports) of Georgia in 2005 to that in 2007?
Your answer should be very brief. 0.94. What is the ratio of the Balance of Payment (as % of service exports) of Rwanda in 2005 to that in 2007?
Offer a terse response. 0.7. What is the ratio of the Balance of Payment (as % of service exports) in East Asia (developing only) in 2005 to that in 2008?
Ensure brevity in your answer.  1.1. What is the ratio of the Balance of Payment (as % of service exports) of Faeroe Islands in 2005 to that in 2008?
Provide a short and direct response. 1.03. What is the ratio of the Balance of Payment (as % of service exports) in Georgia in 2005 to that in 2008?
Make the answer very short. 0.93. What is the ratio of the Balance of Payment (as % of service exports) of Rwanda in 2005 to that in 2008?
Your response must be concise. 0.95. What is the ratio of the Balance of Payment (as % of service exports) of East Asia (developing only) in 2005 to that in 2009?
Your response must be concise. 1.04. What is the ratio of the Balance of Payment (as % of service exports) in Faeroe Islands in 2005 to that in 2009?
Make the answer very short. 1.04. What is the ratio of the Balance of Payment (as % of service exports) in Georgia in 2005 to that in 2009?
Provide a short and direct response. 0.91. What is the ratio of the Balance of Payment (as % of service exports) in Rwanda in 2005 to that in 2009?
Provide a succinct answer. 0.84. What is the ratio of the Balance of Payment (as % of service exports) in East Asia (developing only) in 2005 to that in 2010?
Ensure brevity in your answer.  1.05. What is the ratio of the Balance of Payment (as % of service exports) of Faeroe Islands in 2005 to that in 2010?
Ensure brevity in your answer.  1.18. What is the ratio of the Balance of Payment (as % of service exports) of Georgia in 2005 to that in 2010?
Your answer should be very brief. 0.81. What is the ratio of the Balance of Payment (as % of service exports) of Rwanda in 2005 to that in 2010?
Your answer should be compact. 0.66. What is the ratio of the Balance of Payment (as % of service exports) of East Asia (developing only) in 2005 to that in 2011?
Make the answer very short. 1.03. What is the ratio of the Balance of Payment (as % of service exports) in Faeroe Islands in 2005 to that in 2011?
Your answer should be compact. 1.29. What is the ratio of the Balance of Payment (as % of service exports) of Georgia in 2005 to that in 2011?
Your answer should be very brief. 0.69. What is the ratio of the Balance of Payment (as % of service exports) in Rwanda in 2005 to that in 2011?
Provide a short and direct response. 0.72. What is the ratio of the Balance of Payment (as % of service exports) of East Asia (developing only) in 2006 to that in 2007?
Your answer should be very brief. 1.08. What is the ratio of the Balance of Payment (as % of service exports) in Faeroe Islands in 2006 to that in 2007?
Provide a succinct answer. 0.87. What is the ratio of the Balance of Payment (as % of service exports) of Georgia in 2006 to that in 2007?
Offer a terse response. 0.99. What is the ratio of the Balance of Payment (as % of service exports) in Rwanda in 2006 to that in 2007?
Offer a very short reply. 1.02. What is the ratio of the Balance of Payment (as % of service exports) in East Asia (developing only) in 2006 to that in 2008?
Your answer should be very brief. 1.11. What is the ratio of the Balance of Payment (as % of service exports) of Faeroe Islands in 2006 to that in 2008?
Keep it short and to the point. 0.98. What is the ratio of the Balance of Payment (as % of service exports) in Georgia in 2006 to that in 2008?
Your response must be concise. 0.97. What is the ratio of the Balance of Payment (as % of service exports) of Rwanda in 2006 to that in 2008?
Give a very brief answer. 1.37. What is the ratio of the Balance of Payment (as % of service exports) in East Asia (developing only) in 2006 to that in 2009?
Keep it short and to the point. 1.05. What is the ratio of the Balance of Payment (as % of service exports) of Faeroe Islands in 2006 to that in 2009?
Offer a terse response. 0.99. What is the ratio of the Balance of Payment (as % of service exports) of Georgia in 2006 to that in 2009?
Ensure brevity in your answer.  0.96. What is the ratio of the Balance of Payment (as % of service exports) of Rwanda in 2006 to that in 2009?
Offer a terse response. 1.22. What is the ratio of the Balance of Payment (as % of service exports) in East Asia (developing only) in 2006 to that in 2010?
Offer a terse response. 1.06. What is the ratio of the Balance of Payment (as % of service exports) in Faeroe Islands in 2006 to that in 2010?
Keep it short and to the point. 1.12. What is the ratio of the Balance of Payment (as % of service exports) in Georgia in 2006 to that in 2010?
Provide a succinct answer. 0.85. What is the ratio of the Balance of Payment (as % of service exports) of Rwanda in 2006 to that in 2010?
Offer a very short reply. 0.95. What is the ratio of the Balance of Payment (as % of service exports) of East Asia (developing only) in 2006 to that in 2011?
Provide a short and direct response. 1.04. What is the ratio of the Balance of Payment (as % of service exports) in Faeroe Islands in 2006 to that in 2011?
Give a very brief answer. 1.23. What is the ratio of the Balance of Payment (as % of service exports) in Georgia in 2006 to that in 2011?
Offer a very short reply. 0.72. What is the ratio of the Balance of Payment (as % of service exports) in Rwanda in 2006 to that in 2011?
Offer a very short reply. 1.05. What is the ratio of the Balance of Payment (as % of service exports) in East Asia (developing only) in 2007 to that in 2008?
Keep it short and to the point. 1.03. What is the ratio of the Balance of Payment (as % of service exports) in Faeroe Islands in 2007 to that in 2008?
Give a very brief answer. 1.13. What is the ratio of the Balance of Payment (as % of service exports) of Georgia in 2007 to that in 2008?
Ensure brevity in your answer.  0.99. What is the ratio of the Balance of Payment (as % of service exports) of Rwanda in 2007 to that in 2008?
Offer a very short reply. 1.35. What is the ratio of the Balance of Payment (as % of service exports) of East Asia (developing only) in 2007 to that in 2009?
Give a very brief answer. 0.97. What is the ratio of the Balance of Payment (as % of service exports) in Faeroe Islands in 2007 to that in 2009?
Provide a short and direct response. 1.15. What is the ratio of the Balance of Payment (as % of service exports) of Georgia in 2007 to that in 2009?
Your answer should be compact. 0.97. What is the ratio of the Balance of Payment (as % of service exports) of Rwanda in 2007 to that in 2009?
Offer a very short reply. 1.2. What is the ratio of the Balance of Payment (as % of service exports) in East Asia (developing only) in 2007 to that in 2010?
Make the answer very short. 0.98. What is the ratio of the Balance of Payment (as % of service exports) in Faeroe Islands in 2007 to that in 2010?
Provide a succinct answer. 1.29. What is the ratio of the Balance of Payment (as % of service exports) in Georgia in 2007 to that in 2010?
Your answer should be compact. 0.86. What is the ratio of the Balance of Payment (as % of service exports) of Rwanda in 2007 to that in 2010?
Provide a short and direct response. 0.93. What is the ratio of the Balance of Payment (as % of service exports) in East Asia (developing only) in 2007 to that in 2011?
Your answer should be very brief. 0.96. What is the ratio of the Balance of Payment (as % of service exports) in Faeroe Islands in 2007 to that in 2011?
Offer a very short reply. 1.42. What is the ratio of the Balance of Payment (as % of service exports) in Georgia in 2007 to that in 2011?
Your answer should be compact. 0.73. What is the ratio of the Balance of Payment (as % of service exports) in Rwanda in 2007 to that in 2011?
Keep it short and to the point. 1.03. What is the ratio of the Balance of Payment (as % of service exports) of East Asia (developing only) in 2008 to that in 2009?
Ensure brevity in your answer.  0.94. What is the ratio of the Balance of Payment (as % of service exports) of Faeroe Islands in 2008 to that in 2009?
Provide a short and direct response. 1.02. What is the ratio of the Balance of Payment (as % of service exports) of Georgia in 2008 to that in 2009?
Your answer should be compact. 0.98. What is the ratio of the Balance of Payment (as % of service exports) in Rwanda in 2008 to that in 2009?
Give a very brief answer. 0.89. What is the ratio of the Balance of Payment (as % of service exports) in East Asia (developing only) in 2008 to that in 2010?
Offer a very short reply. 0.95. What is the ratio of the Balance of Payment (as % of service exports) of Faeroe Islands in 2008 to that in 2010?
Keep it short and to the point. 1.15. What is the ratio of the Balance of Payment (as % of service exports) of Georgia in 2008 to that in 2010?
Make the answer very short. 0.87. What is the ratio of the Balance of Payment (as % of service exports) in Rwanda in 2008 to that in 2010?
Make the answer very short. 0.69. What is the ratio of the Balance of Payment (as % of service exports) in East Asia (developing only) in 2008 to that in 2011?
Ensure brevity in your answer.  0.93. What is the ratio of the Balance of Payment (as % of service exports) of Faeroe Islands in 2008 to that in 2011?
Make the answer very short. 1.26. What is the ratio of the Balance of Payment (as % of service exports) of Georgia in 2008 to that in 2011?
Provide a succinct answer. 0.74. What is the ratio of the Balance of Payment (as % of service exports) in Rwanda in 2008 to that in 2011?
Offer a very short reply. 0.77. What is the ratio of the Balance of Payment (as % of service exports) in East Asia (developing only) in 2009 to that in 2010?
Your answer should be very brief. 1.01. What is the ratio of the Balance of Payment (as % of service exports) in Faeroe Islands in 2009 to that in 2010?
Keep it short and to the point. 1.13. What is the ratio of the Balance of Payment (as % of service exports) in Georgia in 2009 to that in 2010?
Give a very brief answer. 0.89. What is the ratio of the Balance of Payment (as % of service exports) in Rwanda in 2009 to that in 2010?
Your answer should be compact. 0.78. What is the ratio of the Balance of Payment (as % of service exports) in Faeroe Islands in 2009 to that in 2011?
Give a very brief answer. 1.24. What is the ratio of the Balance of Payment (as % of service exports) in Georgia in 2009 to that in 2011?
Provide a short and direct response. 0.76. What is the ratio of the Balance of Payment (as % of service exports) in Rwanda in 2009 to that in 2011?
Your answer should be very brief. 0.86. What is the ratio of the Balance of Payment (as % of service exports) in East Asia (developing only) in 2010 to that in 2011?
Give a very brief answer. 0.98. What is the ratio of the Balance of Payment (as % of service exports) in Faeroe Islands in 2010 to that in 2011?
Keep it short and to the point. 1.1. What is the ratio of the Balance of Payment (as % of service exports) in Georgia in 2010 to that in 2011?
Provide a short and direct response. 0.85. What is the ratio of the Balance of Payment (as % of service exports) of Rwanda in 2010 to that in 2011?
Ensure brevity in your answer.  1.1. What is the difference between the highest and the second highest Balance of Payment (as % of service exports) in East Asia (developing only)?
Offer a terse response. 0.34. What is the difference between the highest and the second highest Balance of Payment (as % of service exports) in Faeroe Islands?
Your response must be concise. 2.53. What is the difference between the highest and the second highest Balance of Payment (as % of service exports) of Georgia?
Ensure brevity in your answer.  7.12. What is the difference between the highest and the second highest Balance of Payment (as % of service exports) of Rwanda?
Your answer should be compact. 3.07. What is the difference between the highest and the lowest Balance of Payment (as % of service exports) of East Asia (developing only)?
Keep it short and to the point. 3.73. What is the difference between the highest and the lowest Balance of Payment (as % of service exports) of Faeroe Islands?
Provide a short and direct response. 8.37. What is the difference between the highest and the lowest Balance of Payment (as % of service exports) of Georgia?
Provide a short and direct response. 14.58. What is the difference between the highest and the lowest Balance of Payment (as % of service exports) of Rwanda?
Provide a short and direct response. 21.3. 